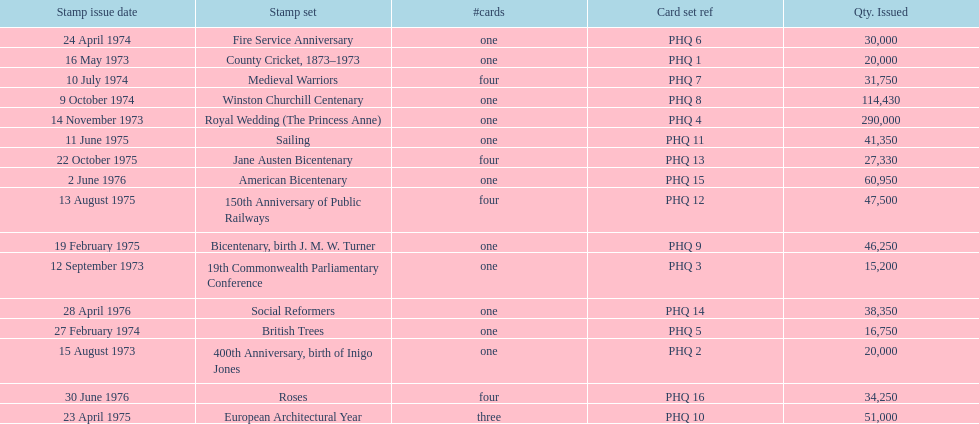How many stamp sets were released in the year 1975? 5. 